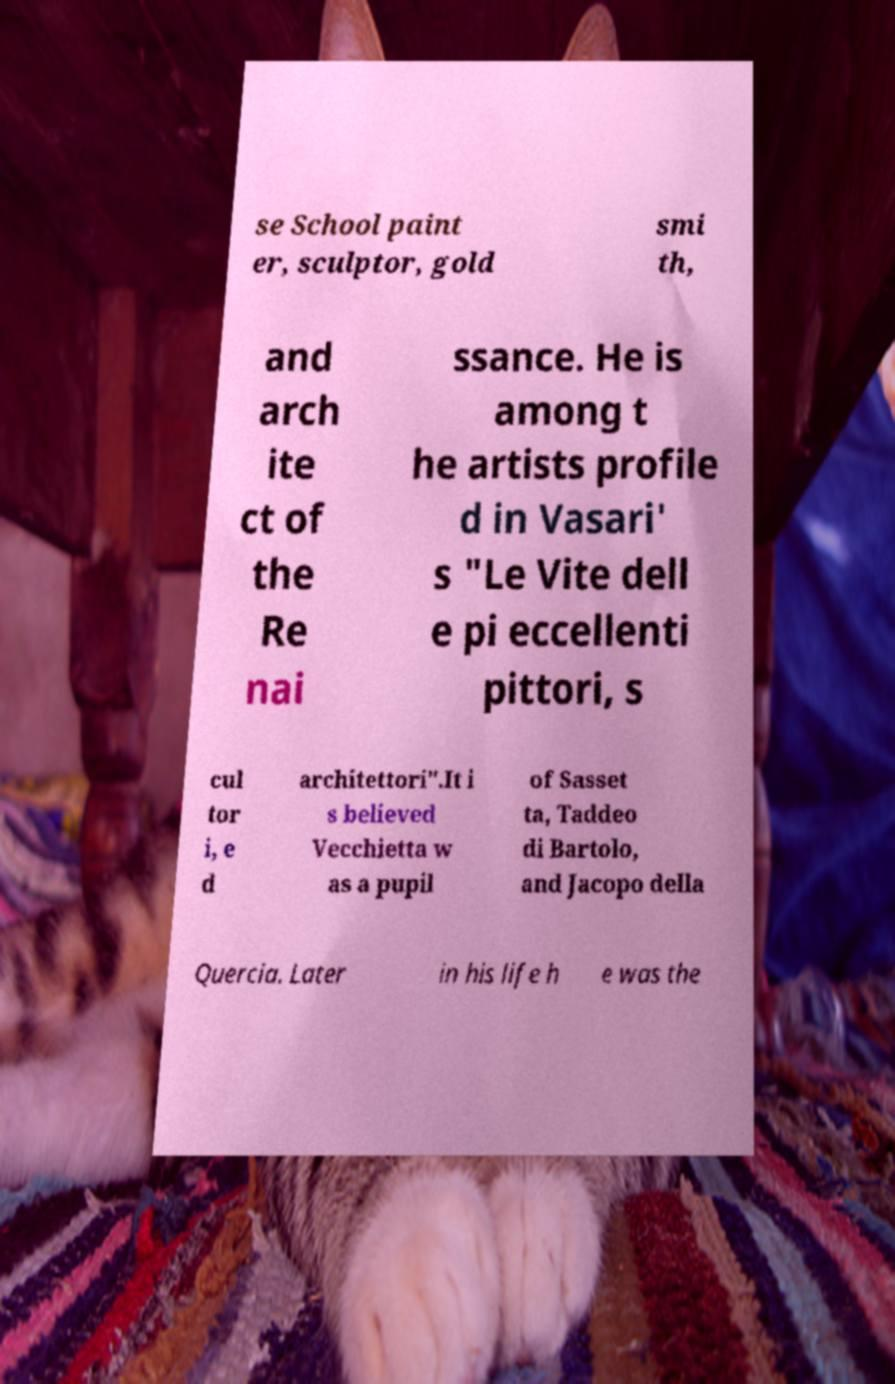Can you accurately transcribe the text from the provided image for me? se School paint er, sculptor, gold smi th, and arch ite ct of the Re nai ssance. He is among t he artists profile d in Vasari' s "Le Vite dell e pi eccellenti pittori, s cul tor i, e d architettori".It i s believed Vecchietta w as a pupil of Sasset ta, Taddeo di Bartolo, and Jacopo della Quercia. Later in his life h e was the 